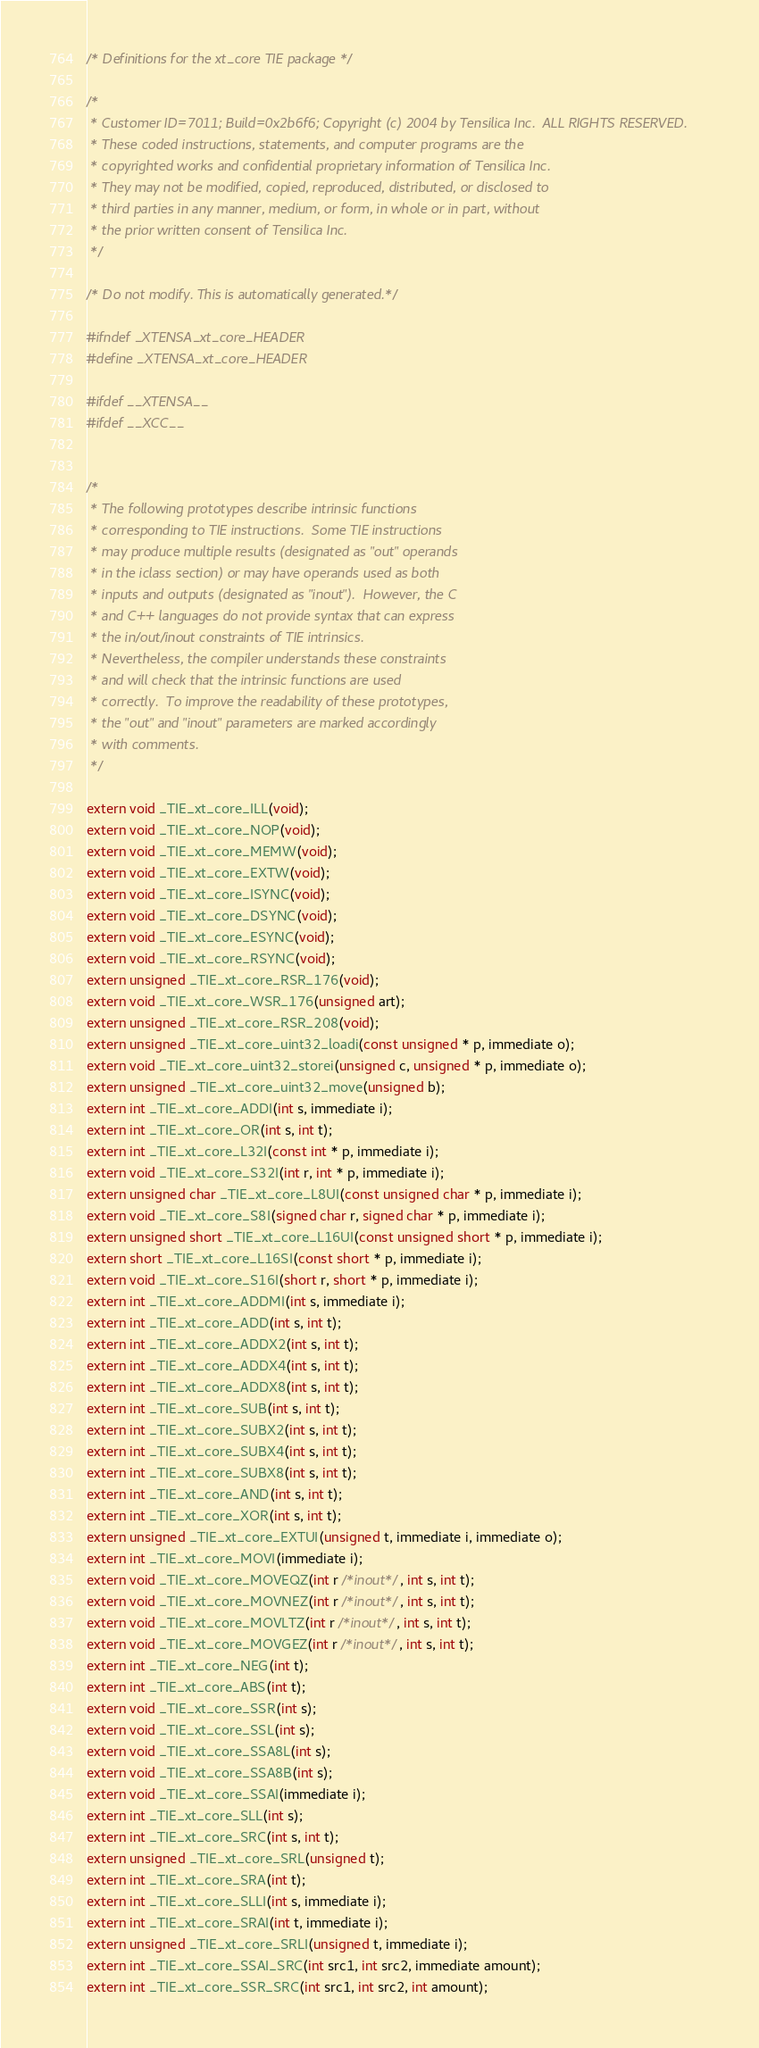<code> <loc_0><loc_0><loc_500><loc_500><_C_>/* Definitions for the xt_core TIE package */

/*
 * Customer ID=7011; Build=0x2b6f6; Copyright (c) 2004 by Tensilica Inc.  ALL RIGHTS RESERVED.
 * These coded instructions, statements, and computer programs are the
 * copyrighted works and confidential proprietary information of Tensilica Inc.
 * They may not be modified, copied, reproduced, distributed, or disclosed to
 * third parties in any manner, medium, or form, in whole or in part, without
 * the prior written consent of Tensilica Inc.
 */

/* Do not modify. This is automatically generated.*/

#ifndef _XTENSA_xt_core_HEADER
#define _XTENSA_xt_core_HEADER

#ifdef __XTENSA__
#ifdef __XCC__


/*
 * The following prototypes describe intrinsic functions
 * corresponding to TIE instructions.  Some TIE instructions
 * may produce multiple results (designated as "out" operands
 * in the iclass section) or may have operands used as both
 * inputs and outputs (designated as "inout").  However, the C
 * and C++ languages do not provide syntax that can express
 * the in/out/inout constraints of TIE intrinsics.
 * Nevertheless, the compiler understands these constraints
 * and will check that the intrinsic functions are used
 * correctly.  To improve the readability of these prototypes,
 * the "out" and "inout" parameters are marked accordingly
 * with comments.
 */

extern void _TIE_xt_core_ILL(void);
extern void _TIE_xt_core_NOP(void);
extern void _TIE_xt_core_MEMW(void);
extern void _TIE_xt_core_EXTW(void);
extern void _TIE_xt_core_ISYNC(void);
extern void _TIE_xt_core_DSYNC(void);
extern void _TIE_xt_core_ESYNC(void);
extern void _TIE_xt_core_RSYNC(void);
extern unsigned _TIE_xt_core_RSR_176(void);
extern void _TIE_xt_core_WSR_176(unsigned art);
extern unsigned _TIE_xt_core_RSR_208(void);
extern unsigned _TIE_xt_core_uint32_loadi(const unsigned * p, immediate o);
extern void _TIE_xt_core_uint32_storei(unsigned c, unsigned * p, immediate o);
extern unsigned _TIE_xt_core_uint32_move(unsigned b);
extern int _TIE_xt_core_ADDI(int s, immediate i);
extern int _TIE_xt_core_OR(int s, int t);
extern int _TIE_xt_core_L32I(const int * p, immediate i);
extern void _TIE_xt_core_S32I(int r, int * p, immediate i);
extern unsigned char _TIE_xt_core_L8UI(const unsigned char * p, immediate i);
extern void _TIE_xt_core_S8I(signed char r, signed char * p, immediate i);
extern unsigned short _TIE_xt_core_L16UI(const unsigned short * p, immediate i);
extern short _TIE_xt_core_L16SI(const short * p, immediate i);
extern void _TIE_xt_core_S16I(short r, short * p, immediate i);
extern int _TIE_xt_core_ADDMI(int s, immediate i);
extern int _TIE_xt_core_ADD(int s, int t);
extern int _TIE_xt_core_ADDX2(int s, int t);
extern int _TIE_xt_core_ADDX4(int s, int t);
extern int _TIE_xt_core_ADDX8(int s, int t);
extern int _TIE_xt_core_SUB(int s, int t);
extern int _TIE_xt_core_SUBX2(int s, int t);
extern int _TIE_xt_core_SUBX4(int s, int t);
extern int _TIE_xt_core_SUBX8(int s, int t);
extern int _TIE_xt_core_AND(int s, int t);
extern int _TIE_xt_core_XOR(int s, int t);
extern unsigned _TIE_xt_core_EXTUI(unsigned t, immediate i, immediate o);
extern int _TIE_xt_core_MOVI(immediate i);
extern void _TIE_xt_core_MOVEQZ(int r /*inout*/, int s, int t);
extern void _TIE_xt_core_MOVNEZ(int r /*inout*/, int s, int t);
extern void _TIE_xt_core_MOVLTZ(int r /*inout*/, int s, int t);
extern void _TIE_xt_core_MOVGEZ(int r /*inout*/, int s, int t);
extern int _TIE_xt_core_NEG(int t);
extern int _TIE_xt_core_ABS(int t);
extern void _TIE_xt_core_SSR(int s);
extern void _TIE_xt_core_SSL(int s);
extern void _TIE_xt_core_SSA8L(int s);
extern void _TIE_xt_core_SSA8B(int s);
extern void _TIE_xt_core_SSAI(immediate i);
extern int _TIE_xt_core_SLL(int s);
extern int _TIE_xt_core_SRC(int s, int t);
extern unsigned _TIE_xt_core_SRL(unsigned t);
extern int _TIE_xt_core_SRA(int t);
extern int _TIE_xt_core_SLLI(int s, immediate i);
extern int _TIE_xt_core_SRAI(int t, immediate i);
extern unsigned _TIE_xt_core_SRLI(unsigned t, immediate i);
extern int _TIE_xt_core_SSAI_SRC(int src1, int src2, immediate amount);
extern int _TIE_xt_core_SSR_SRC(int src1, int src2, int amount);</code> 